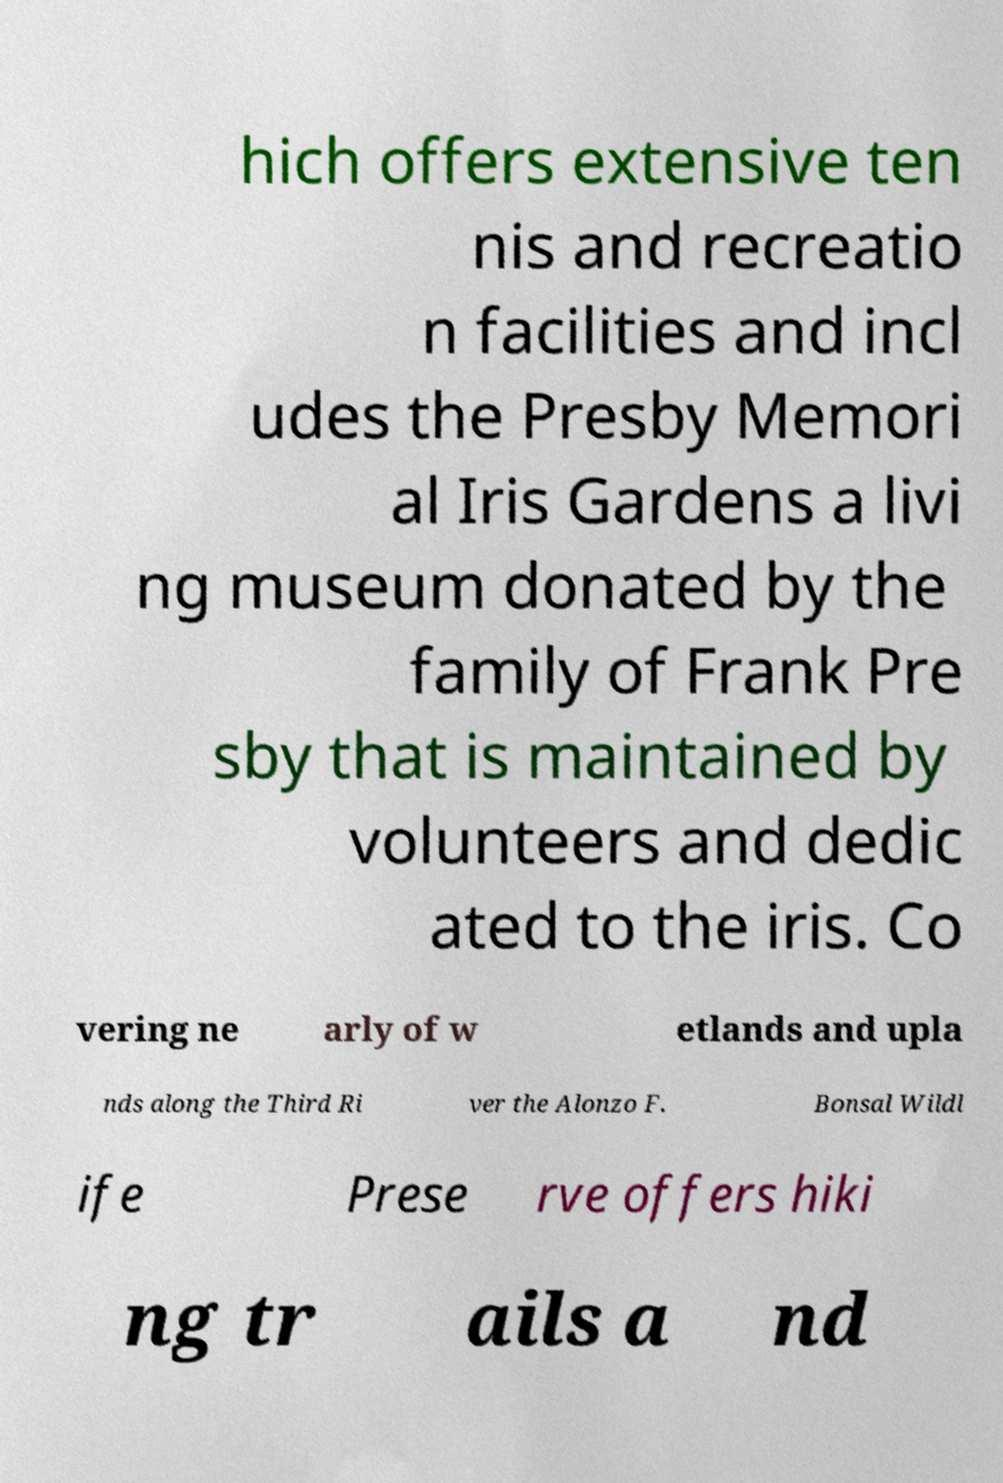Could you assist in decoding the text presented in this image and type it out clearly? hich offers extensive ten nis and recreatio n facilities and incl udes the Presby Memori al Iris Gardens a livi ng museum donated by the family of Frank Pre sby that is maintained by volunteers and dedic ated to the iris. Co vering ne arly of w etlands and upla nds along the Third Ri ver the Alonzo F. Bonsal Wildl ife Prese rve offers hiki ng tr ails a nd 